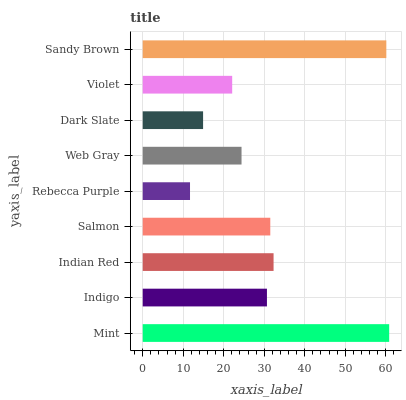Is Rebecca Purple the minimum?
Answer yes or no. Yes. Is Mint the maximum?
Answer yes or no. Yes. Is Indigo the minimum?
Answer yes or no. No. Is Indigo the maximum?
Answer yes or no. No. Is Mint greater than Indigo?
Answer yes or no. Yes. Is Indigo less than Mint?
Answer yes or no. Yes. Is Indigo greater than Mint?
Answer yes or no. No. Is Mint less than Indigo?
Answer yes or no. No. Is Indigo the high median?
Answer yes or no. Yes. Is Indigo the low median?
Answer yes or no. Yes. Is Web Gray the high median?
Answer yes or no. No. Is Violet the low median?
Answer yes or no. No. 